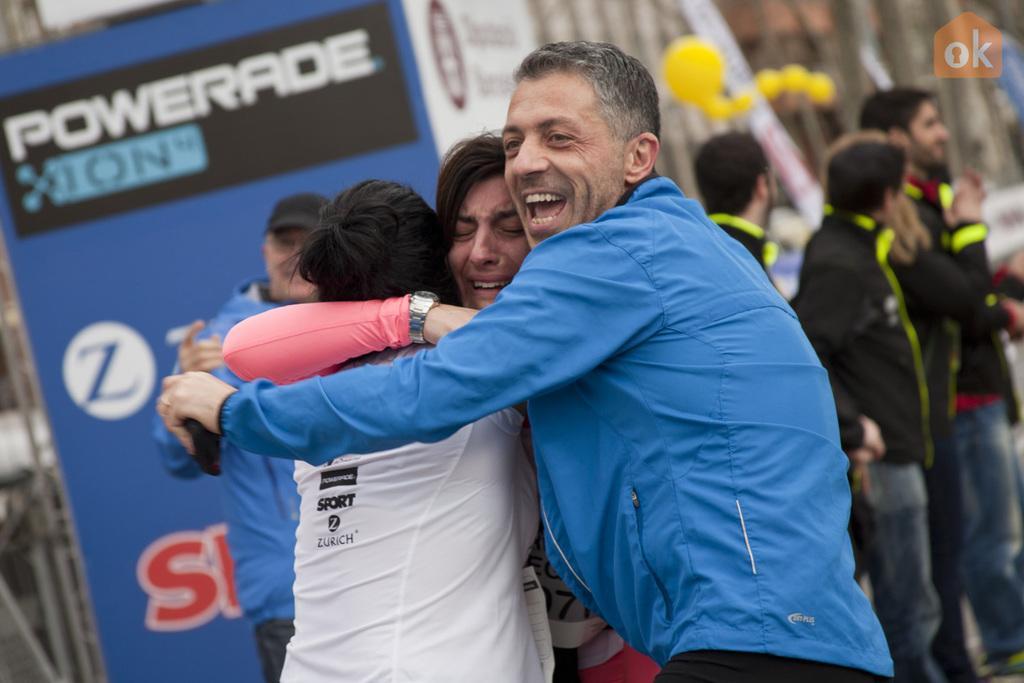Describe this image in one or two sentences. In this image in the foreground there are three who are hugging each other and one person is smiling and one person is crying. In the background there are some people who are standing, and also there are some boards and buildings. 